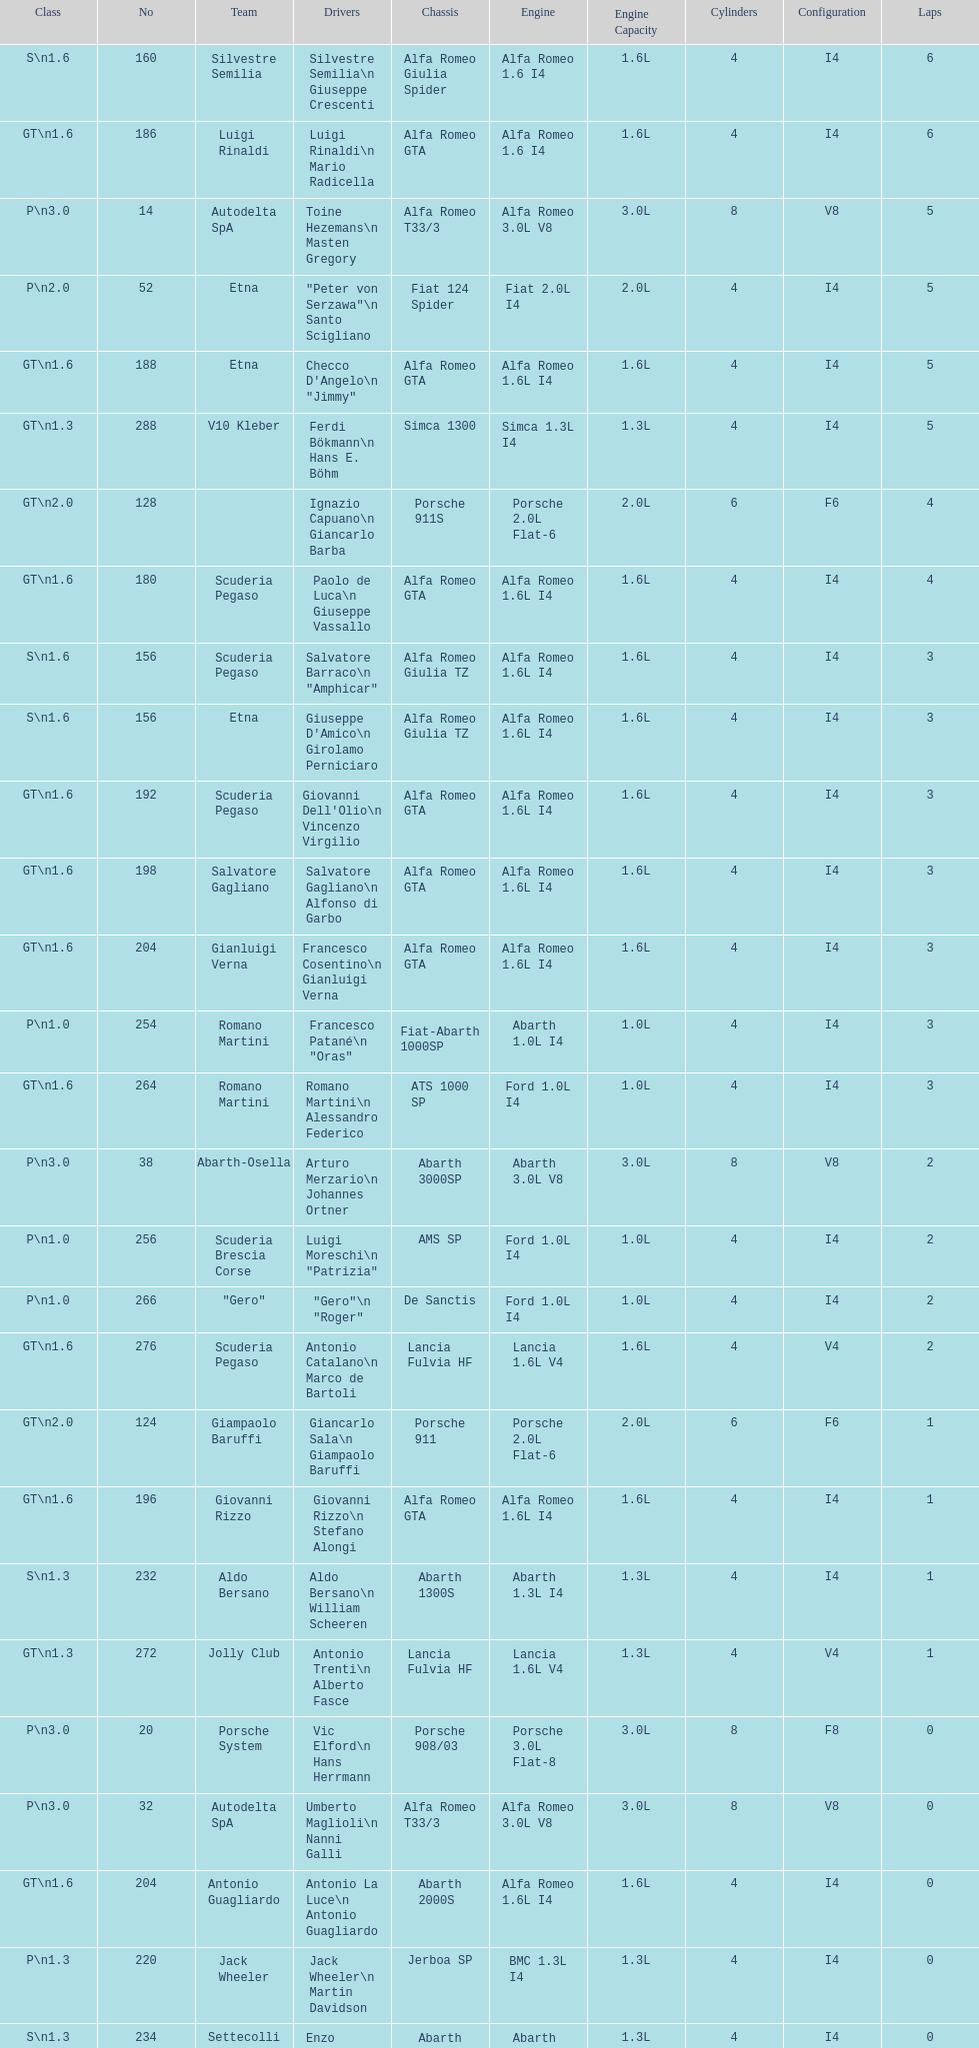How many teams failed to finish the race after 2 laps? 4. 